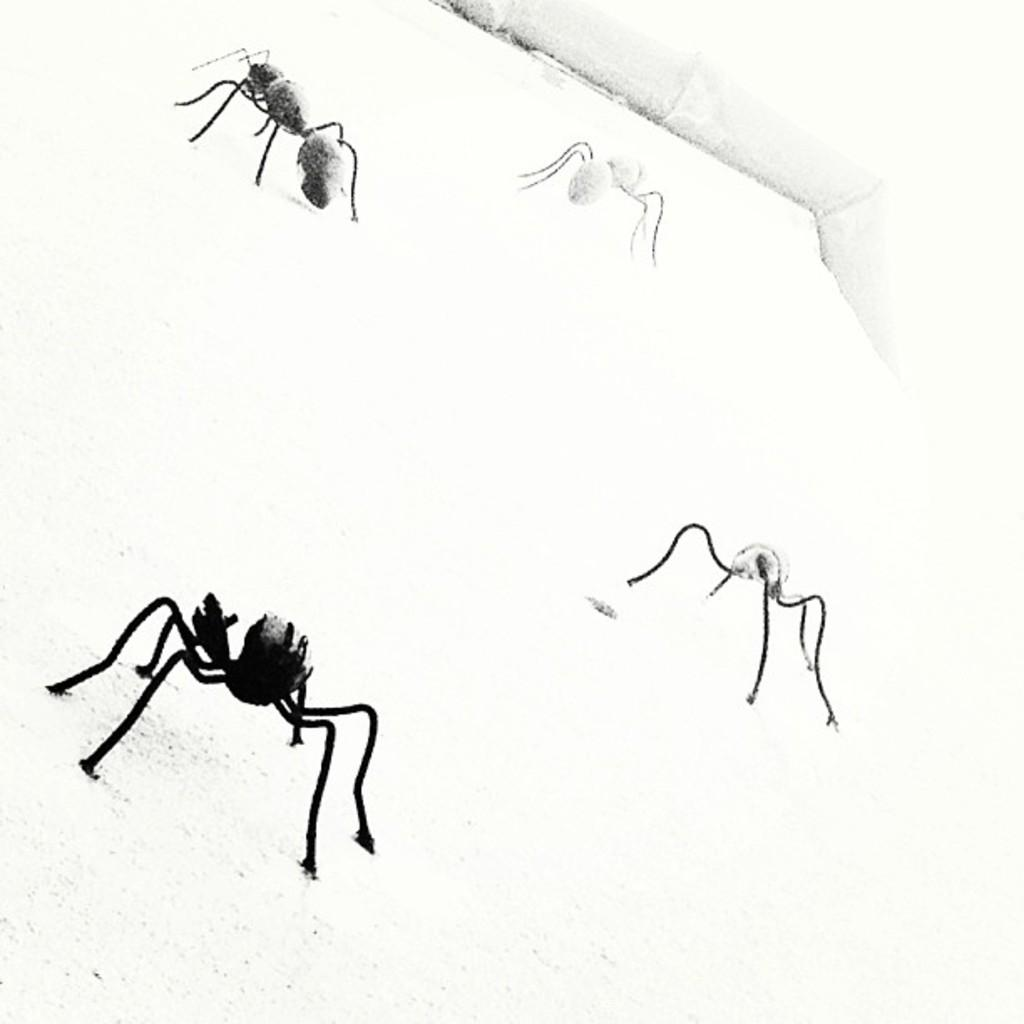What is the main subject of the sketch in the image? The sketch depicts insects. What type of medium is the sketch drawn on? The sketch is on a paper. What country is the sketch of insects from in the image? The facts provided do not mention any country related to the sketch, so it cannot be determined from the image. What type of root can be seen growing from the insects in the sketch? There is no root visible in the sketch, as it only depicts insects. 